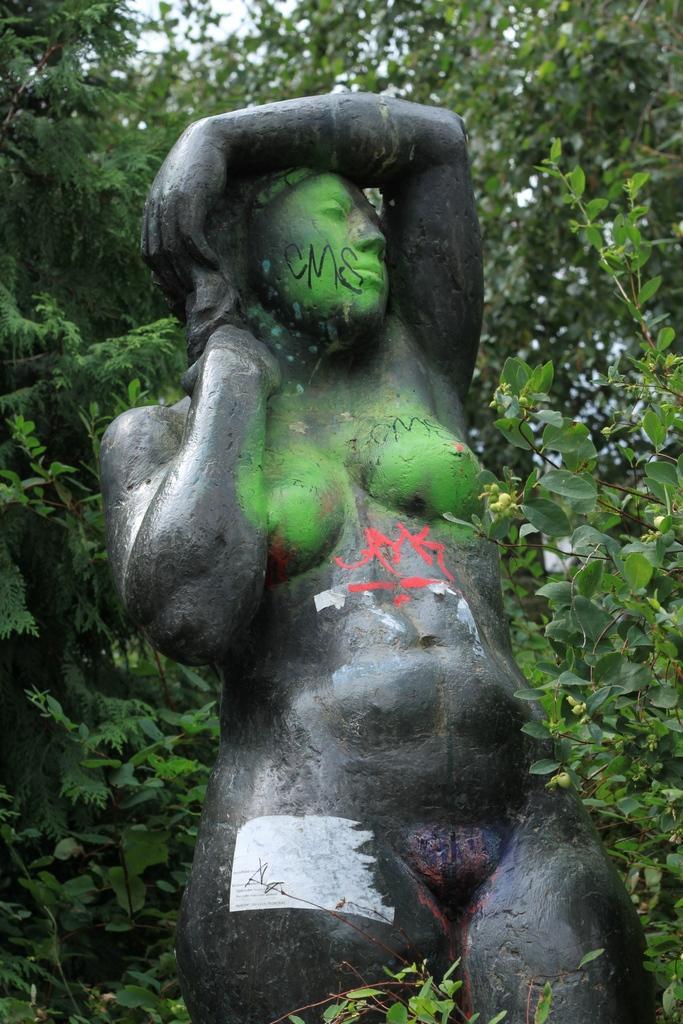Please provide a concise description of this image. In this image I can see a black colored statue of a person and on it I can see a painting with black and red color. I can see few trees around the statue and in the background I can see the sky. 